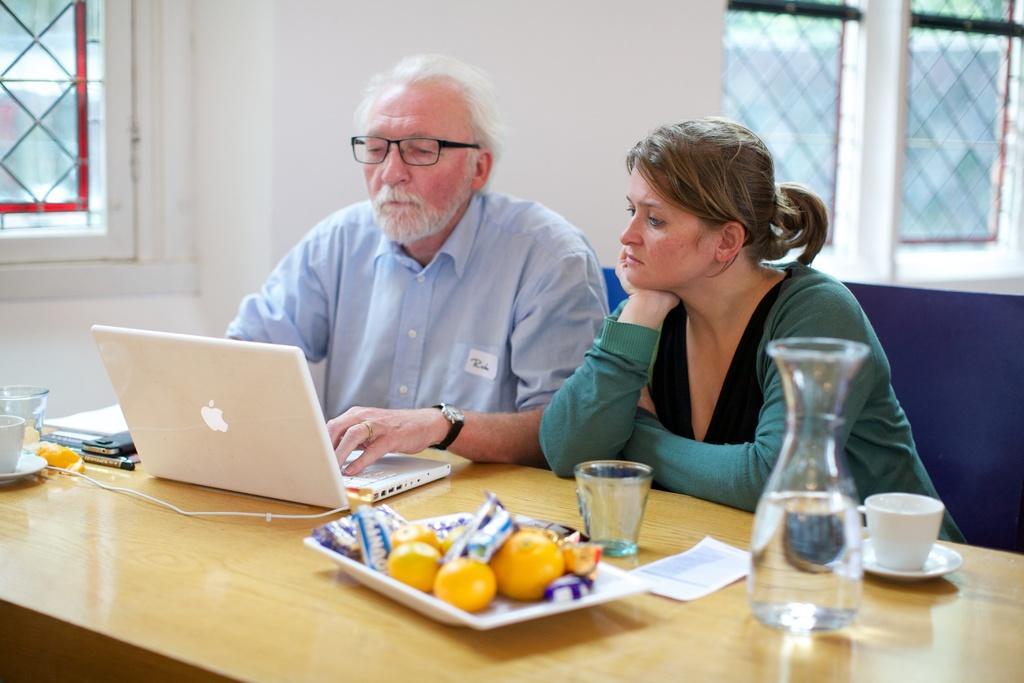Describe this image in one or two sentences. In this image i can see a women and a man siting on a chair and doing work in a laptop there are few fruits in a plate, a glass, a bottle on a table at the back ground i can see a wall and a window. 